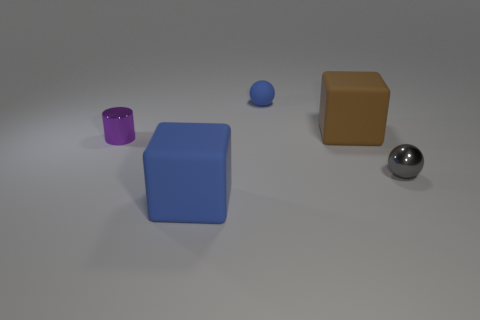There is another thing that is the same color as the small matte object; what size is it?
Your response must be concise. Large. Does the object that is in front of the gray shiny sphere have the same color as the sphere that is left of the small gray object?
Give a very brief answer. Yes. How many balls have the same size as the cylinder?
Make the answer very short. 2. Is the number of brown rubber cubes that are in front of the brown rubber block the same as the number of shiny cylinders on the left side of the gray metallic ball?
Give a very brief answer. No. Are the tiny gray object and the large brown object made of the same material?
Your answer should be compact. No. Is there a tiny gray ball that is behind the block that is to the right of the tiny blue rubber thing?
Your answer should be very brief. No. Are there any big blue rubber objects that have the same shape as the brown object?
Make the answer very short. Yes. The small purple object that is behind the tiny object that is in front of the small metallic cylinder is made of what material?
Your answer should be very brief. Metal. What is the size of the brown rubber block?
Your response must be concise. Large. What is the size of the gray thing that is the same material as the cylinder?
Give a very brief answer. Small. 